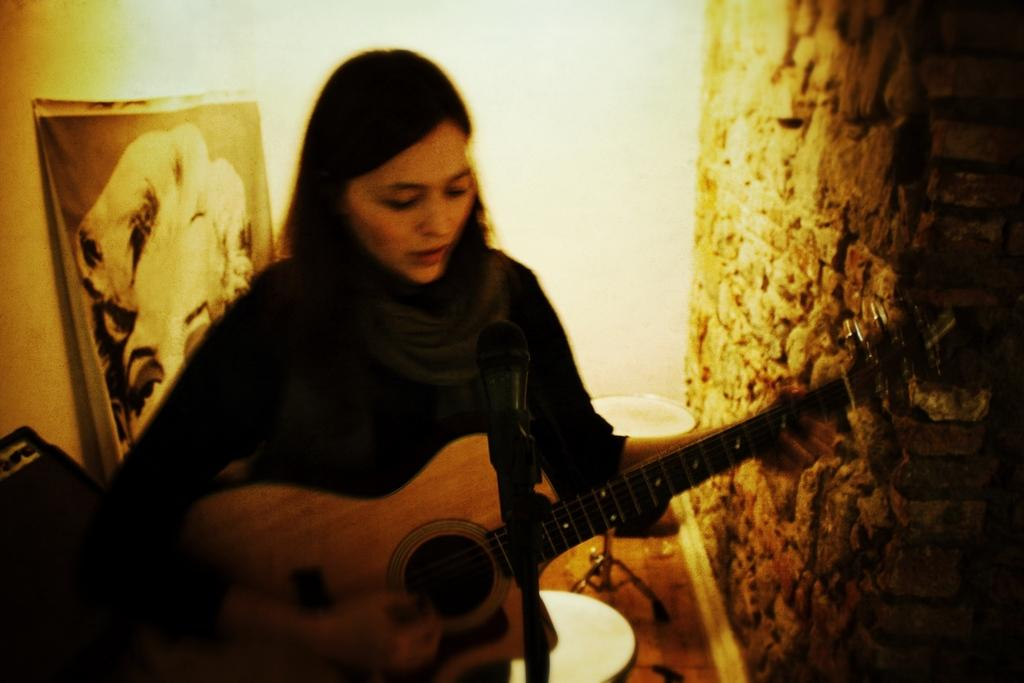What is the main subject of the image? The main subject of the image is a lady person. What is the lady person wearing? The lady person is wearing a black dress. What activity is the lady person engaged in? The lady person is playing a guitar. What object is in front of the lady person? There is a microphone in front of the lady person. What type of dinner is being served in the image? There is no dinner present in the image; it features a lady person playing a guitar with a microphone in front of her. Can you describe the texture of the caption in the image? There is no caption present in the image, so it is not possible to describe its texture. 